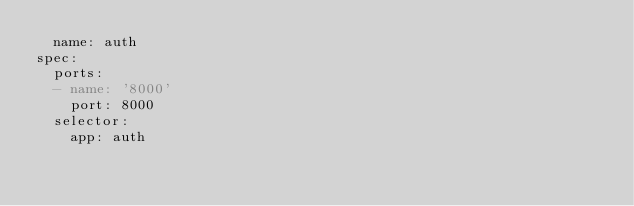Convert code to text. <code><loc_0><loc_0><loc_500><loc_500><_YAML_>  name: auth
spec:
  ports:
  - name: '8000'
    port: 8000
  selector:
    app: auth
</code> 